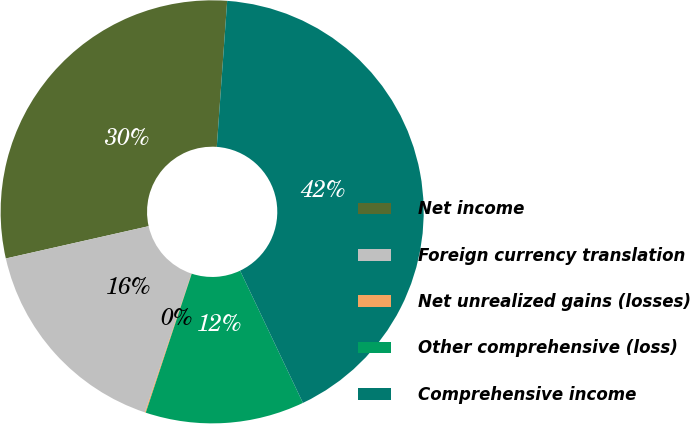Convert chart. <chart><loc_0><loc_0><loc_500><loc_500><pie_chart><fcel>Net income<fcel>Foreign currency translation<fcel>Net unrealized gains (losses)<fcel>Other comprehensive (loss)<fcel>Comprehensive income<nl><fcel>29.67%<fcel>16.31%<fcel>0.07%<fcel>12.14%<fcel>41.81%<nl></chart> 